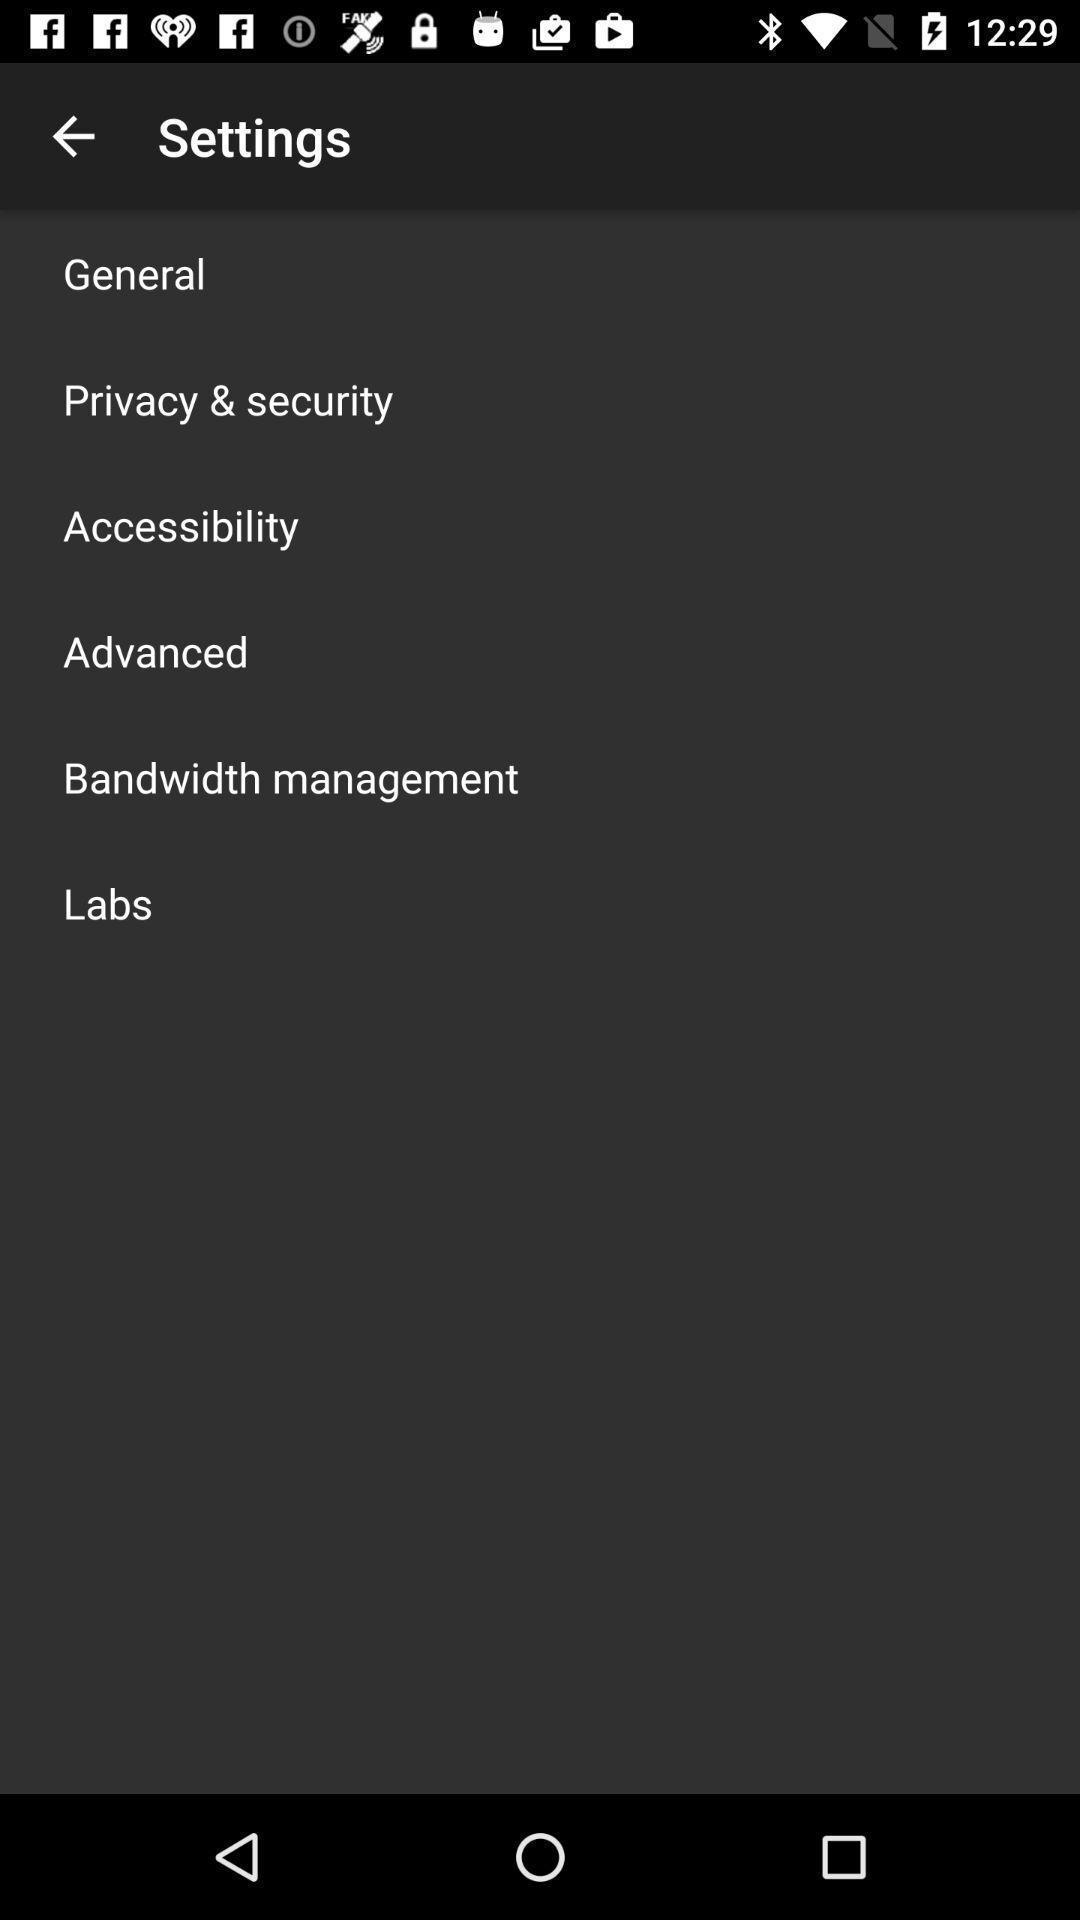Summarize the information in this screenshot. Settings page with various other options in financial application. 